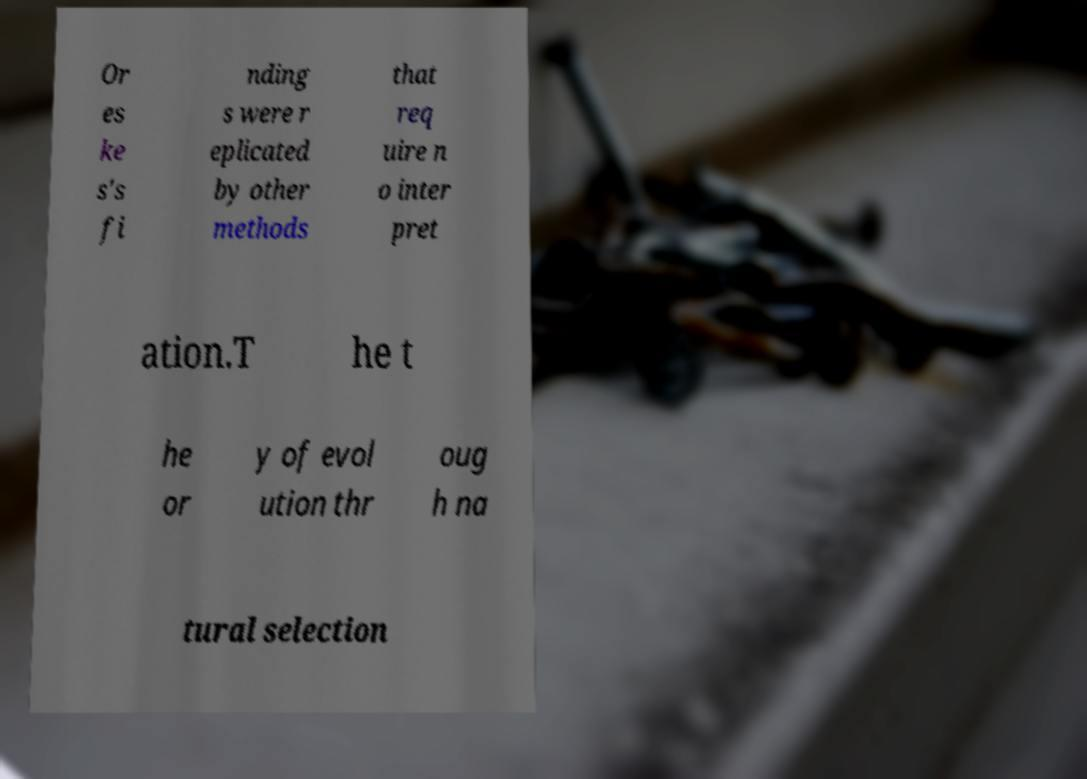I need the written content from this picture converted into text. Can you do that? Or es ke s's fi nding s were r eplicated by other methods that req uire n o inter pret ation.T he t he or y of evol ution thr oug h na tural selection 